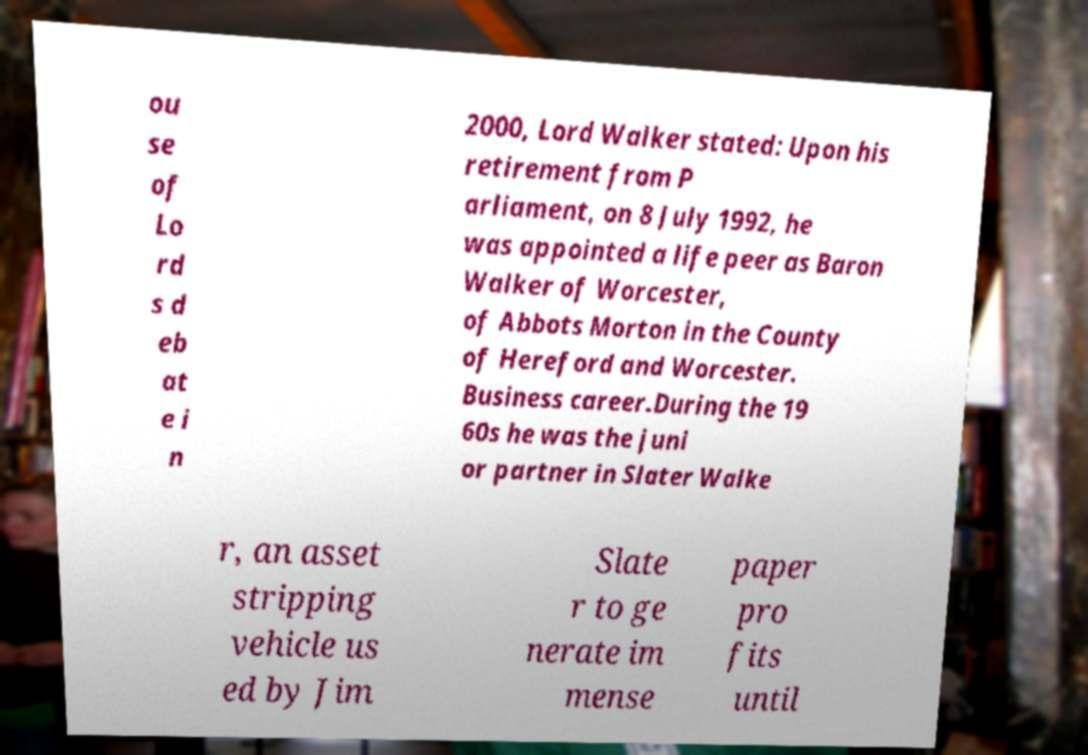Could you assist in decoding the text presented in this image and type it out clearly? ou se of Lo rd s d eb at e i n 2000, Lord Walker stated: Upon his retirement from P arliament, on 8 July 1992, he was appointed a life peer as Baron Walker of Worcester, of Abbots Morton in the County of Hereford and Worcester. Business career.During the 19 60s he was the juni or partner in Slater Walke r, an asset stripping vehicle us ed by Jim Slate r to ge nerate im mense paper pro fits until 